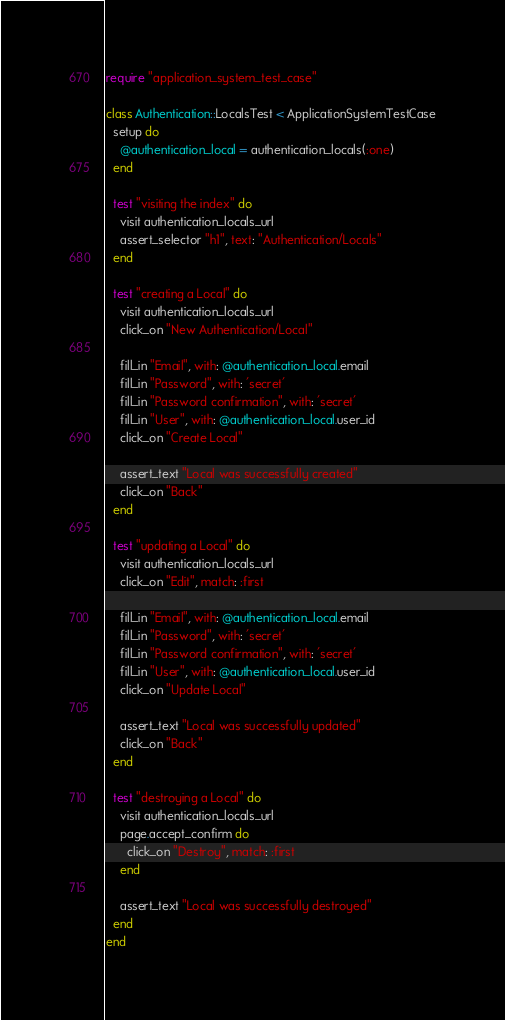<code> <loc_0><loc_0><loc_500><loc_500><_Ruby_>require "application_system_test_case"

class Authentication::LocalsTest < ApplicationSystemTestCase
  setup do
    @authentication_local = authentication_locals(:one)
  end

  test "visiting the index" do
    visit authentication_locals_url
    assert_selector "h1", text: "Authentication/Locals"
  end

  test "creating a Local" do
    visit authentication_locals_url
    click_on "New Authentication/Local"

    fill_in "Email", with: @authentication_local.email
    fill_in "Password", with: 'secret'
    fill_in "Password confirmation", with: 'secret'
    fill_in "User", with: @authentication_local.user_id
    click_on "Create Local"

    assert_text "Local was successfully created"
    click_on "Back"
  end

  test "updating a Local" do
    visit authentication_locals_url
    click_on "Edit", match: :first

    fill_in "Email", with: @authentication_local.email
    fill_in "Password", with: 'secret'
    fill_in "Password confirmation", with: 'secret'
    fill_in "User", with: @authentication_local.user_id
    click_on "Update Local"

    assert_text "Local was successfully updated"
    click_on "Back"
  end

  test "destroying a Local" do
    visit authentication_locals_url
    page.accept_confirm do
      click_on "Destroy", match: :first
    end

    assert_text "Local was successfully destroyed"
  end
end
</code> 